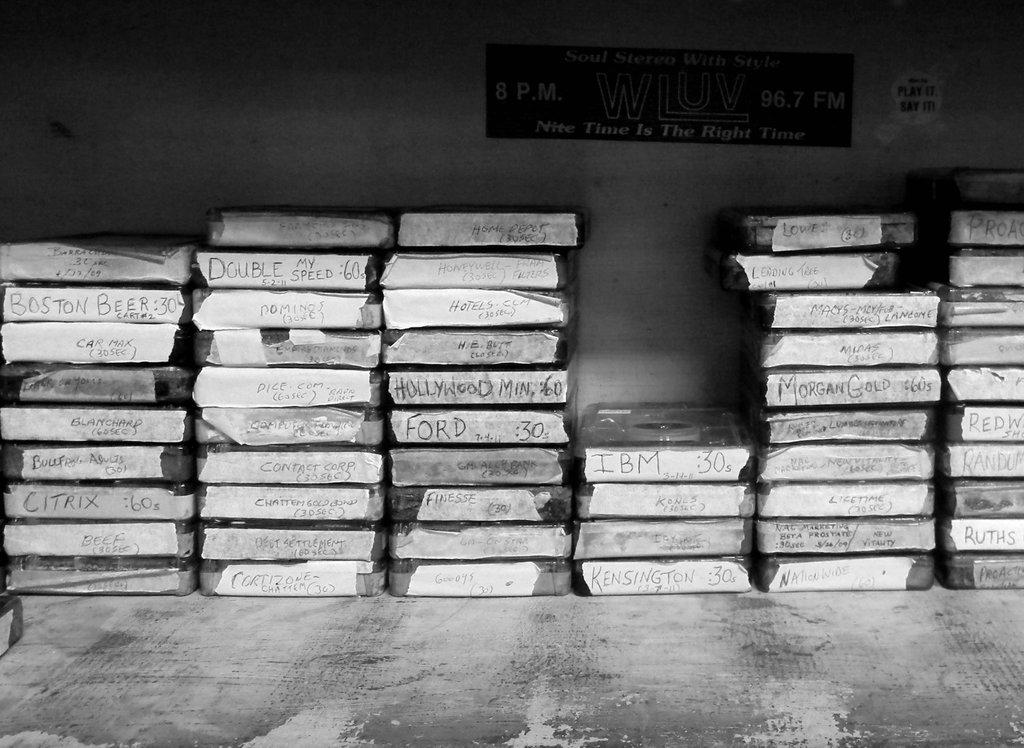What company is written at the top of the shortest stack?
Ensure brevity in your answer.  Ibm. 